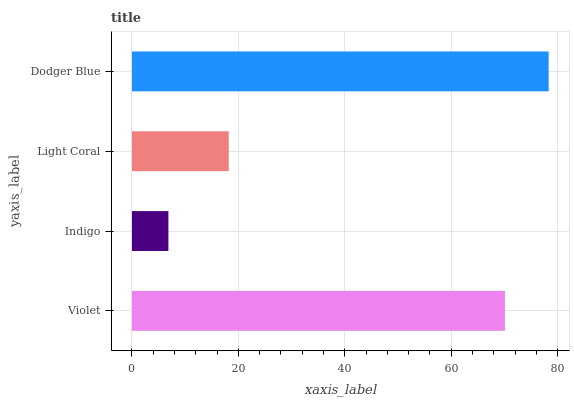Is Indigo the minimum?
Answer yes or no. Yes. Is Dodger Blue the maximum?
Answer yes or no. Yes. Is Light Coral the minimum?
Answer yes or no. No. Is Light Coral the maximum?
Answer yes or no. No. Is Light Coral greater than Indigo?
Answer yes or no. Yes. Is Indigo less than Light Coral?
Answer yes or no. Yes. Is Indigo greater than Light Coral?
Answer yes or no. No. Is Light Coral less than Indigo?
Answer yes or no. No. Is Violet the high median?
Answer yes or no. Yes. Is Light Coral the low median?
Answer yes or no. Yes. Is Indigo the high median?
Answer yes or no. No. Is Violet the low median?
Answer yes or no. No. 